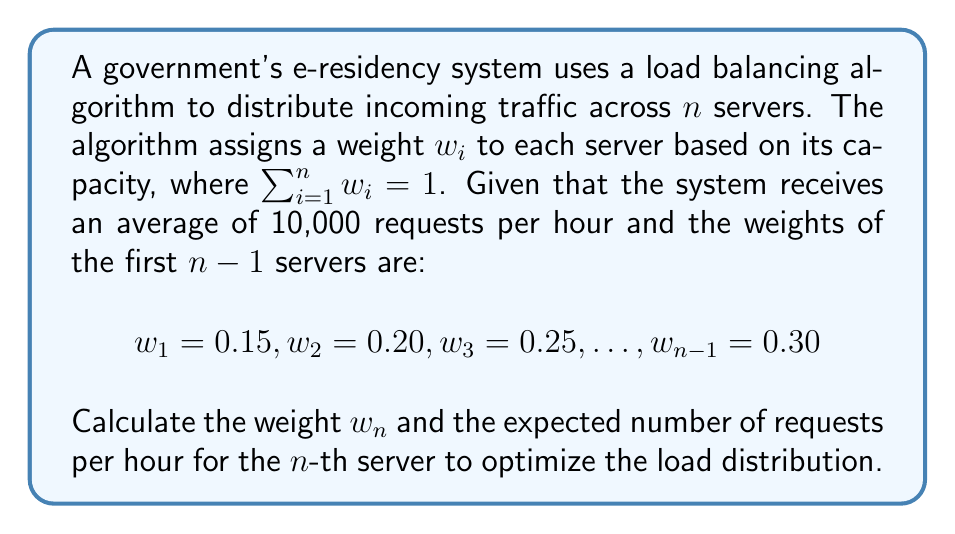Provide a solution to this math problem. To solve this problem, we'll follow these steps:

1. Calculate the sum of weights for the first $n-1$ servers:
   $$\sum_{i=1}^{n-1} w_i = 0.15 + 0.20 + 0.25 + 0.30 = 0.90$$

2. Find the weight of the $n$-th server:
   Since the sum of all weights must equal 1, we can calculate $w_n$ as:
   $$w_n = 1 - \sum_{i=1}^{n-1} w_i = 1 - 0.90 = 0.10$$

3. Calculate the expected number of requests for the $n$-th server:
   The load balancing algorithm distributes requests proportionally to the weights. Given that the system receives 10,000 requests per hour, the expected number of requests for the $n$-th server is:
   $$\text{Requests}_n = 10,000 \times w_n = 10,000 \times 0.10 = 1,000$$

Therefore, the weight of the $n$-th server is 0.10, and it is expected to handle 1,000 requests per hour.
Answer: $w_n = 0.10$, 1,000 requests/hour 